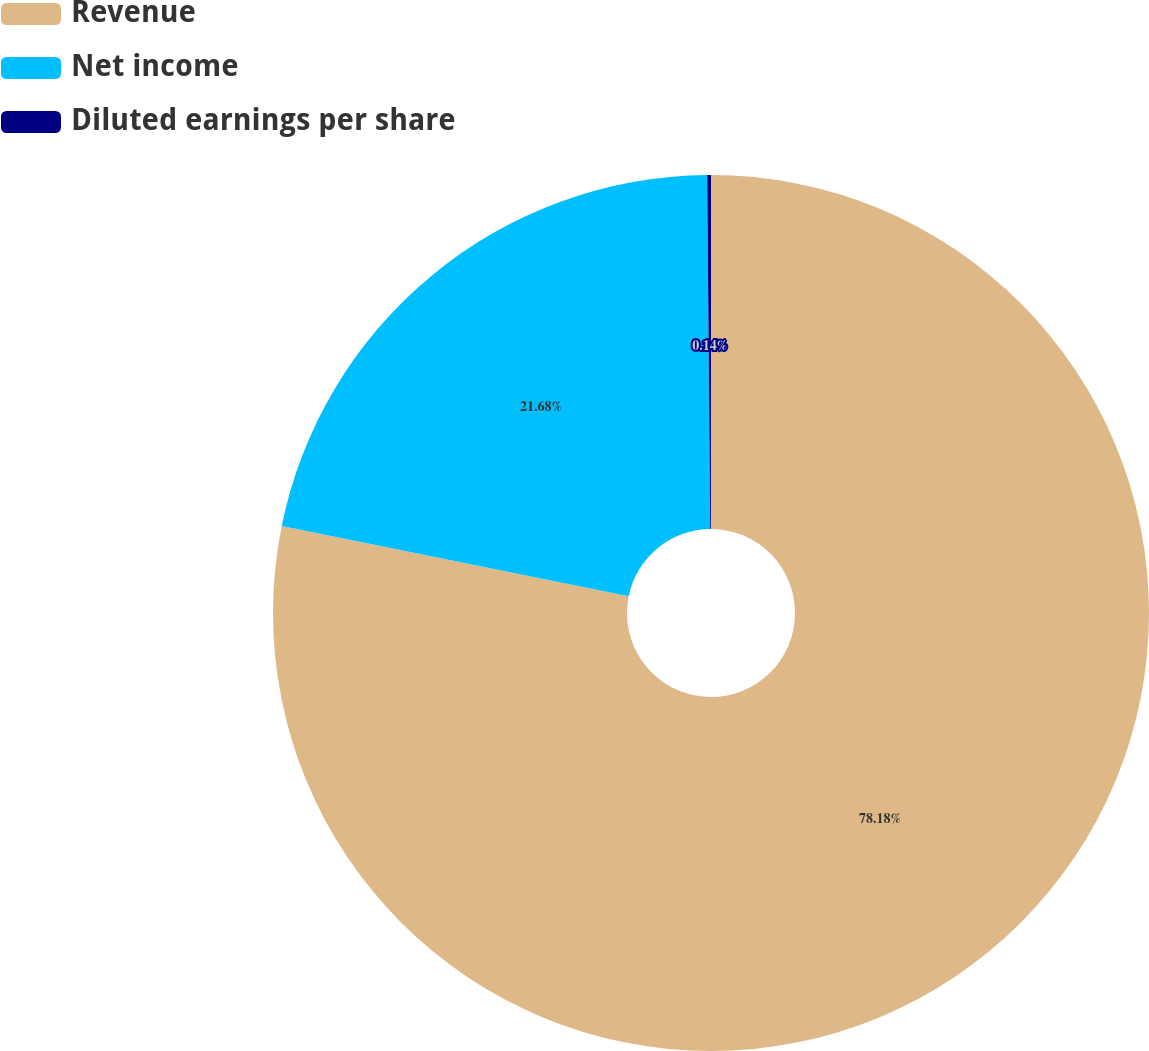<chart> <loc_0><loc_0><loc_500><loc_500><pie_chart><fcel>Revenue<fcel>Net income<fcel>Diluted earnings per share<nl><fcel>78.18%<fcel>21.68%<fcel>0.14%<nl></chart> 